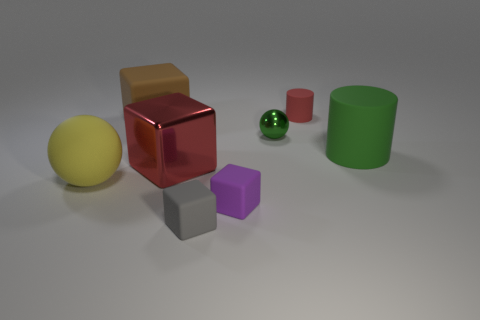There is a red thing behind the green thing that is to the right of the red matte object; what is it made of?
Your answer should be very brief. Rubber. How big is the sphere behind the large yellow ball?
Your answer should be very brief. Small. What number of red objects are matte cylinders or small rubber cylinders?
Give a very brief answer. 1. There is another small object that is the same shape as the yellow object; what is its material?
Keep it short and to the point. Metal. Is the number of small green metallic objects on the left side of the small green shiny object the same as the number of big brown cubes?
Give a very brief answer. No. There is a rubber object that is in front of the small red cylinder and on the right side of the small green metallic ball; what is its size?
Give a very brief answer. Large. Is there any other thing of the same color as the metallic sphere?
Provide a short and direct response. Yes. There is a shiny thing that is in front of the rubber cylinder in front of the green metallic ball; how big is it?
Ensure brevity in your answer.  Large. What is the color of the rubber thing that is both on the left side of the purple rubber object and in front of the yellow rubber thing?
Provide a succinct answer. Gray. How many other things are there of the same size as the green metal thing?
Offer a very short reply. 3. 